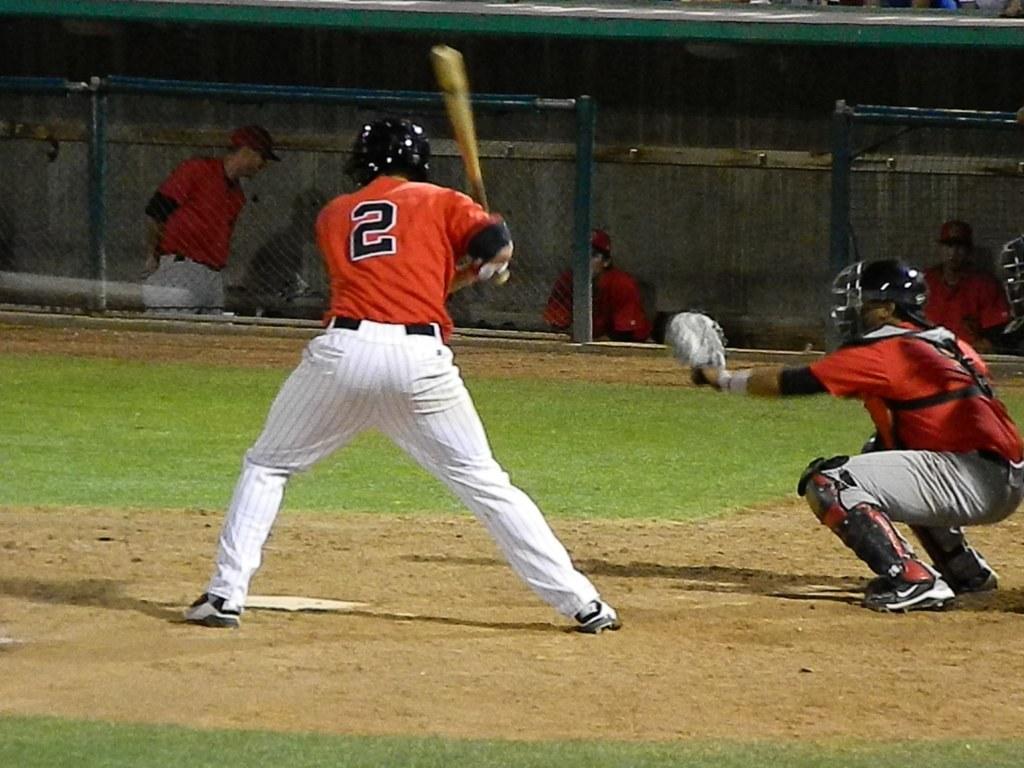What is the number on the batter's jersey?
Your answer should be compact. 2. 